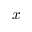<formula> <loc_0><loc_0><loc_500><loc_500>x</formula> 